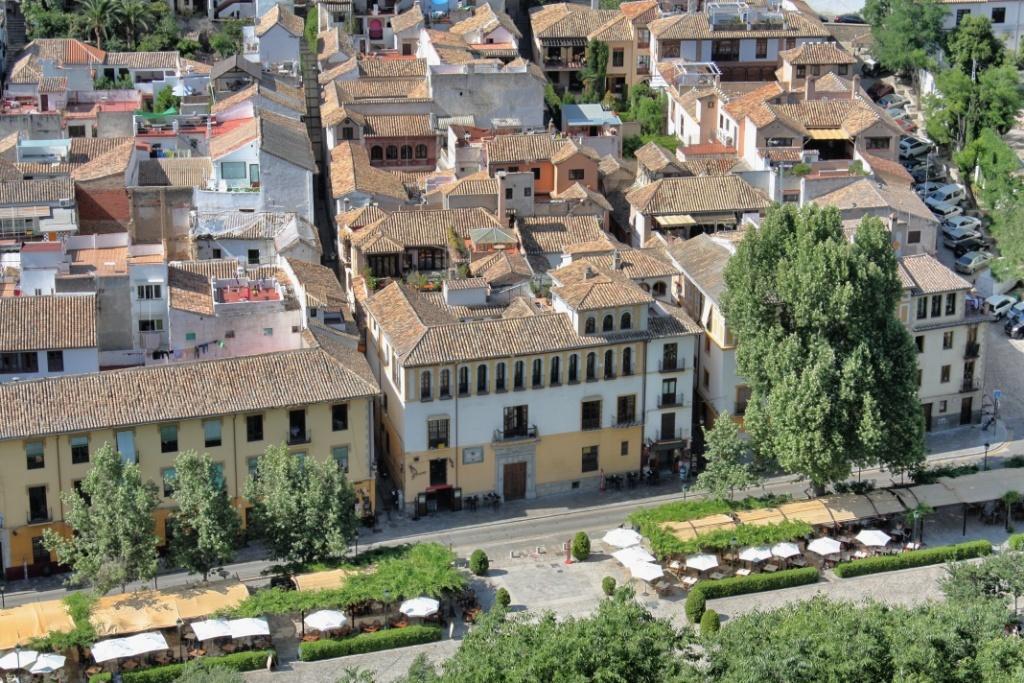How would you summarize this image in a sentence or two? There are trees near a road and garden in which, there are umbrellas and roofs arranged and there are trees. In the background, there is a road, on which there are vehicles parked, there are buildings which are having glass windows and roofs and there are trees. 